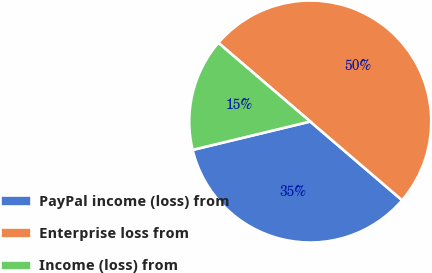Convert chart to OTSL. <chart><loc_0><loc_0><loc_500><loc_500><pie_chart><fcel>PayPal income (loss) from<fcel>Enterprise loss from<fcel>Income (loss) from<nl><fcel>34.96%<fcel>50.0%<fcel>15.04%<nl></chart> 